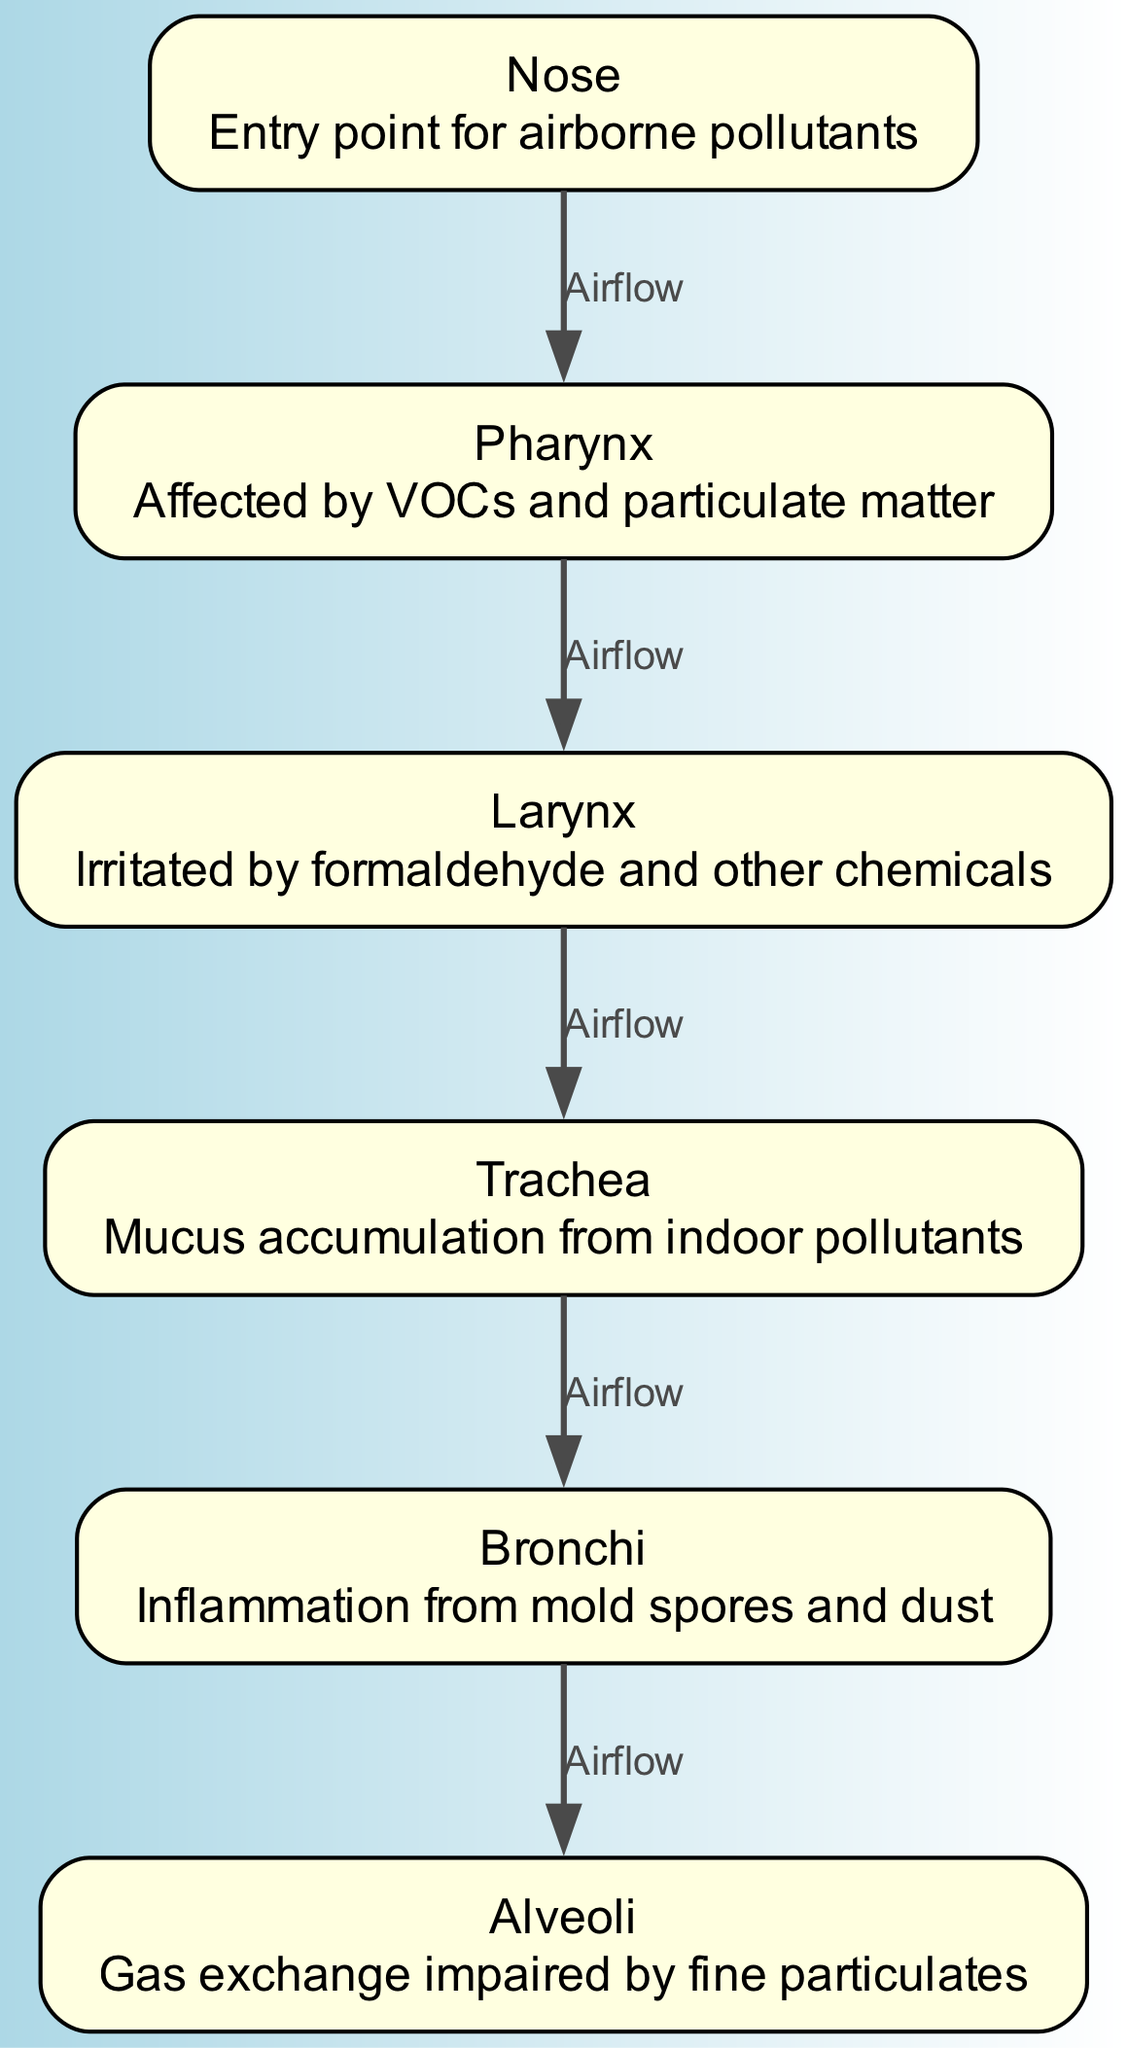What is the entry point for airborne pollutants? The diagram identifies the Nose as the entry point for airborne pollutants. This is explicitly mentioned in the description associated with the Nose node in the diagram.
Answer: Nose How many main areas are highlighted as affected by indoor air pollutants? The diagram features six main areas: Nose, Pharynx, Larynx, Trachea, Bronchi, and Alveoli. Counting the nodes listed provides the total number of areas affected.
Answer: Six Which area is affected by VOCs and particulate matter? The diagram states that the Pharynx is affected by VOCs and particulate matter. This is directly indicated in the description for the Pharynx node in the diagram.
Answer: Pharynx What type of air pollutants irritate the Larynx? According to the diagram, the Larynx is irritated by formaldehyde and other chemicals. The description provided for the Larynx node includes this specific information.
Answer: Formaldehyde Which area experiences mucus accumulation from indoor pollutants? The description associated with the Trachea node specifies that it has mucus accumulation as a result of indoor pollutants. This is stated clearly in the diagram.
Answer: Trachea How does air flow from the Nose to the Alveoli? Airflow starts at the Nose, travels to the Pharynx, then to the Larynx, continues down to the Trachea, goes into the Bronchi, and finally reaches the Alveoli. Each step of the path is indicated by arrows connecting the nodes in the diagram.
Answer: Nose to Pharynx to Larynx to Trachea to Bronchi to Alveoli Which area is indicated to be inflamed by mold spores and dust? The Bronchi is indicated in the diagram as experiencing inflammation due to mold spores and dust. This specific detail is highlighted in the description of the Bronchi node.
Answer: Bronchi What impact does fine particulates have on the Alveoli? The diagram shows that fine particulates impair gas exchange in the Alveoli, as stated in the description for this node. Therefore, the connection between fine particulates and gas exchange impairment is clearly conveyed.
Answer: Impaired gas exchange 